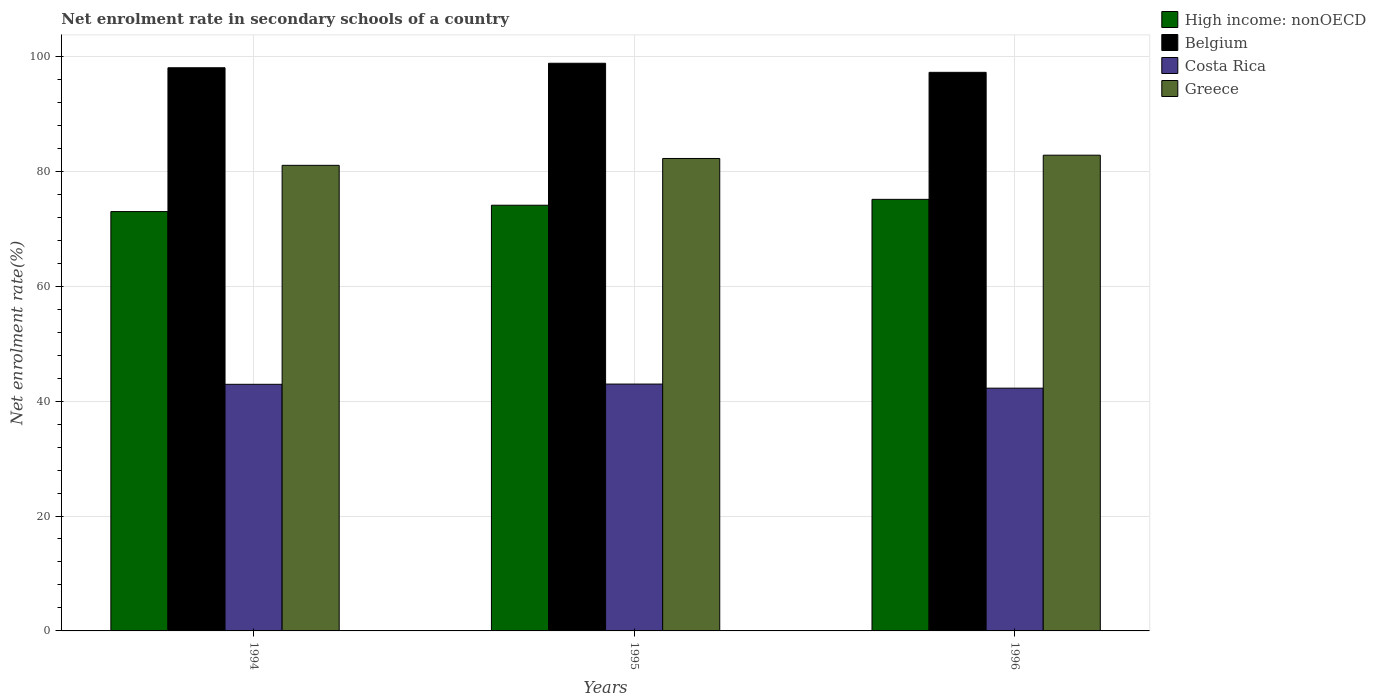How many bars are there on the 1st tick from the left?
Provide a short and direct response. 4. What is the label of the 3rd group of bars from the left?
Offer a very short reply. 1996. What is the net enrolment rate in secondary schools in High income: nonOECD in 1994?
Ensure brevity in your answer.  72.99. Across all years, what is the maximum net enrolment rate in secondary schools in Belgium?
Provide a succinct answer. 98.8. Across all years, what is the minimum net enrolment rate in secondary schools in Greece?
Your response must be concise. 81.04. What is the total net enrolment rate in secondary schools in High income: nonOECD in the graph?
Offer a terse response. 222.2. What is the difference between the net enrolment rate in secondary schools in Greece in 1994 and that in 1995?
Ensure brevity in your answer.  -1.19. What is the difference between the net enrolment rate in secondary schools in High income: nonOECD in 1996 and the net enrolment rate in secondary schools in Costa Rica in 1994?
Give a very brief answer. 32.19. What is the average net enrolment rate in secondary schools in Costa Rica per year?
Provide a short and direct response. 42.71. In the year 1996, what is the difference between the net enrolment rate in secondary schools in High income: nonOECD and net enrolment rate in secondary schools in Costa Rica?
Offer a very short reply. 32.86. What is the ratio of the net enrolment rate in secondary schools in Costa Rica in 1994 to that in 1995?
Give a very brief answer. 1. What is the difference between the highest and the second highest net enrolment rate in secondary schools in High income: nonOECD?
Provide a short and direct response. 1.02. What is the difference between the highest and the lowest net enrolment rate in secondary schools in Costa Rica?
Keep it short and to the point. 0.71. In how many years, is the net enrolment rate in secondary schools in Greece greater than the average net enrolment rate in secondary schools in Greece taken over all years?
Your answer should be very brief. 2. Is the sum of the net enrolment rate in secondary schools in High income: nonOECD in 1994 and 1995 greater than the maximum net enrolment rate in secondary schools in Belgium across all years?
Provide a succinct answer. Yes. Is it the case that in every year, the sum of the net enrolment rate in secondary schools in Costa Rica and net enrolment rate in secondary schools in Belgium is greater than the sum of net enrolment rate in secondary schools in High income: nonOECD and net enrolment rate in secondary schools in Greece?
Provide a succinct answer. Yes. What does the 1st bar from the left in 1995 represents?
Ensure brevity in your answer.  High income: nonOECD. Is it the case that in every year, the sum of the net enrolment rate in secondary schools in High income: nonOECD and net enrolment rate in secondary schools in Greece is greater than the net enrolment rate in secondary schools in Costa Rica?
Offer a terse response. Yes. Are all the bars in the graph horizontal?
Offer a terse response. No. How many years are there in the graph?
Make the answer very short. 3. Are the values on the major ticks of Y-axis written in scientific E-notation?
Offer a terse response. No. Does the graph contain grids?
Your answer should be compact. Yes. How are the legend labels stacked?
Give a very brief answer. Vertical. What is the title of the graph?
Provide a succinct answer. Net enrolment rate in secondary schools of a country. Does "Switzerland" appear as one of the legend labels in the graph?
Provide a succinct answer. No. What is the label or title of the X-axis?
Your answer should be very brief. Years. What is the label or title of the Y-axis?
Ensure brevity in your answer.  Net enrolment rate(%). What is the Net enrolment rate(%) of High income: nonOECD in 1994?
Give a very brief answer. 72.99. What is the Net enrolment rate(%) in Belgium in 1994?
Offer a very short reply. 98.02. What is the Net enrolment rate(%) in Costa Rica in 1994?
Make the answer very short. 42.92. What is the Net enrolment rate(%) of Greece in 1994?
Provide a succinct answer. 81.04. What is the Net enrolment rate(%) of High income: nonOECD in 1995?
Your answer should be compact. 74.09. What is the Net enrolment rate(%) of Belgium in 1995?
Keep it short and to the point. 98.8. What is the Net enrolment rate(%) of Costa Rica in 1995?
Offer a terse response. 42.97. What is the Net enrolment rate(%) of Greece in 1995?
Your answer should be very brief. 82.23. What is the Net enrolment rate(%) in High income: nonOECD in 1996?
Make the answer very short. 75.12. What is the Net enrolment rate(%) in Belgium in 1996?
Offer a terse response. 97.22. What is the Net enrolment rate(%) in Costa Rica in 1996?
Your response must be concise. 42.25. What is the Net enrolment rate(%) in Greece in 1996?
Keep it short and to the point. 82.8. Across all years, what is the maximum Net enrolment rate(%) in High income: nonOECD?
Your response must be concise. 75.12. Across all years, what is the maximum Net enrolment rate(%) in Belgium?
Give a very brief answer. 98.8. Across all years, what is the maximum Net enrolment rate(%) of Costa Rica?
Your response must be concise. 42.97. Across all years, what is the maximum Net enrolment rate(%) in Greece?
Offer a very short reply. 82.8. Across all years, what is the minimum Net enrolment rate(%) of High income: nonOECD?
Provide a short and direct response. 72.99. Across all years, what is the minimum Net enrolment rate(%) of Belgium?
Provide a short and direct response. 97.22. Across all years, what is the minimum Net enrolment rate(%) of Costa Rica?
Offer a very short reply. 42.25. Across all years, what is the minimum Net enrolment rate(%) in Greece?
Ensure brevity in your answer.  81.04. What is the total Net enrolment rate(%) of High income: nonOECD in the graph?
Offer a very short reply. 222.2. What is the total Net enrolment rate(%) of Belgium in the graph?
Your answer should be compact. 294.04. What is the total Net enrolment rate(%) of Costa Rica in the graph?
Give a very brief answer. 128.14. What is the total Net enrolment rate(%) of Greece in the graph?
Offer a very short reply. 246.07. What is the difference between the Net enrolment rate(%) in High income: nonOECD in 1994 and that in 1995?
Your answer should be very brief. -1.1. What is the difference between the Net enrolment rate(%) in Belgium in 1994 and that in 1995?
Make the answer very short. -0.78. What is the difference between the Net enrolment rate(%) in Costa Rica in 1994 and that in 1995?
Give a very brief answer. -0.04. What is the difference between the Net enrolment rate(%) of Greece in 1994 and that in 1995?
Provide a succinct answer. -1.19. What is the difference between the Net enrolment rate(%) of High income: nonOECD in 1994 and that in 1996?
Offer a very short reply. -2.13. What is the difference between the Net enrolment rate(%) of Belgium in 1994 and that in 1996?
Ensure brevity in your answer.  0.8. What is the difference between the Net enrolment rate(%) of Costa Rica in 1994 and that in 1996?
Offer a terse response. 0.67. What is the difference between the Net enrolment rate(%) in Greece in 1994 and that in 1996?
Offer a very short reply. -1.76. What is the difference between the Net enrolment rate(%) of High income: nonOECD in 1995 and that in 1996?
Give a very brief answer. -1.02. What is the difference between the Net enrolment rate(%) in Belgium in 1995 and that in 1996?
Provide a short and direct response. 1.58. What is the difference between the Net enrolment rate(%) in Costa Rica in 1995 and that in 1996?
Keep it short and to the point. 0.71. What is the difference between the Net enrolment rate(%) of Greece in 1995 and that in 1996?
Make the answer very short. -0.57. What is the difference between the Net enrolment rate(%) in High income: nonOECD in 1994 and the Net enrolment rate(%) in Belgium in 1995?
Give a very brief answer. -25.81. What is the difference between the Net enrolment rate(%) of High income: nonOECD in 1994 and the Net enrolment rate(%) of Costa Rica in 1995?
Offer a very short reply. 30.02. What is the difference between the Net enrolment rate(%) of High income: nonOECD in 1994 and the Net enrolment rate(%) of Greece in 1995?
Your answer should be very brief. -9.24. What is the difference between the Net enrolment rate(%) in Belgium in 1994 and the Net enrolment rate(%) in Costa Rica in 1995?
Offer a very short reply. 55.05. What is the difference between the Net enrolment rate(%) of Belgium in 1994 and the Net enrolment rate(%) of Greece in 1995?
Your answer should be very brief. 15.79. What is the difference between the Net enrolment rate(%) of Costa Rica in 1994 and the Net enrolment rate(%) of Greece in 1995?
Make the answer very short. -39.31. What is the difference between the Net enrolment rate(%) in High income: nonOECD in 1994 and the Net enrolment rate(%) in Belgium in 1996?
Keep it short and to the point. -24.23. What is the difference between the Net enrolment rate(%) in High income: nonOECD in 1994 and the Net enrolment rate(%) in Costa Rica in 1996?
Offer a very short reply. 30.74. What is the difference between the Net enrolment rate(%) of High income: nonOECD in 1994 and the Net enrolment rate(%) of Greece in 1996?
Your answer should be very brief. -9.81. What is the difference between the Net enrolment rate(%) in Belgium in 1994 and the Net enrolment rate(%) in Costa Rica in 1996?
Provide a succinct answer. 55.77. What is the difference between the Net enrolment rate(%) of Belgium in 1994 and the Net enrolment rate(%) of Greece in 1996?
Provide a short and direct response. 15.22. What is the difference between the Net enrolment rate(%) in Costa Rica in 1994 and the Net enrolment rate(%) in Greece in 1996?
Keep it short and to the point. -39.88. What is the difference between the Net enrolment rate(%) of High income: nonOECD in 1995 and the Net enrolment rate(%) of Belgium in 1996?
Make the answer very short. -23.13. What is the difference between the Net enrolment rate(%) of High income: nonOECD in 1995 and the Net enrolment rate(%) of Costa Rica in 1996?
Provide a succinct answer. 31.84. What is the difference between the Net enrolment rate(%) of High income: nonOECD in 1995 and the Net enrolment rate(%) of Greece in 1996?
Give a very brief answer. -8.71. What is the difference between the Net enrolment rate(%) in Belgium in 1995 and the Net enrolment rate(%) in Costa Rica in 1996?
Provide a succinct answer. 56.55. What is the difference between the Net enrolment rate(%) of Belgium in 1995 and the Net enrolment rate(%) of Greece in 1996?
Make the answer very short. 16. What is the difference between the Net enrolment rate(%) in Costa Rica in 1995 and the Net enrolment rate(%) in Greece in 1996?
Your answer should be compact. -39.83. What is the average Net enrolment rate(%) of High income: nonOECD per year?
Make the answer very short. 74.07. What is the average Net enrolment rate(%) in Belgium per year?
Ensure brevity in your answer.  98.02. What is the average Net enrolment rate(%) of Costa Rica per year?
Ensure brevity in your answer.  42.71. What is the average Net enrolment rate(%) of Greece per year?
Provide a short and direct response. 82.02. In the year 1994, what is the difference between the Net enrolment rate(%) in High income: nonOECD and Net enrolment rate(%) in Belgium?
Offer a terse response. -25.03. In the year 1994, what is the difference between the Net enrolment rate(%) in High income: nonOECD and Net enrolment rate(%) in Costa Rica?
Your response must be concise. 30.06. In the year 1994, what is the difference between the Net enrolment rate(%) of High income: nonOECD and Net enrolment rate(%) of Greece?
Ensure brevity in your answer.  -8.05. In the year 1994, what is the difference between the Net enrolment rate(%) of Belgium and Net enrolment rate(%) of Costa Rica?
Your answer should be compact. 55.09. In the year 1994, what is the difference between the Net enrolment rate(%) of Belgium and Net enrolment rate(%) of Greece?
Give a very brief answer. 16.98. In the year 1994, what is the difference between the Net enrolment rate(%) in Costa Rica and Net enrolment rate(%) in Greece?
Offer a very short reply. -38.11. In the year 1995, what is the difference between the Net enrolment rate(%) of High income: nonOECD and Net enrolment rate(%) of Belgium?
Ensure brevity in your answer.  -24.71. In the year 1995, what is the difference between the Net enrolment rate(%) in High income: nonOECD and Net enrolment rate(%) in Costa Rica?
Make the answer very short. 31.13. In the year 1995, what is the difference between the Net enrolment rate(%) in High income: nonOECD and Net enrolment rate(%) in Greece?
Provide a succinct answer. -8.14. In the year 1995, what is the difference between the Net enrolment rate(%) in Belgium and Net enrolment rate(%) in Costa Rica?
Offer a very short reply. 55.84. In the year 1995, what is the difference between the Net enrolment rate(%) of Belgium and Net enrolment rate(%) of Greece?
Ensure brevity in your answer.  16.57. In the year 1995, what is the difference between the Net enrolment rate(%) in Costa Rica and Net enrolment rate(%) in Greece?
Provide a succinct answer. -39.26. In the year 1996, what is the difference between the Net enrolment rate(%) of High income: nonOECD and Net enrolment rate(%) of Belgium?
Give a very brief answer. -22.11. In the year 1996, what is the difference between the Net enrolment rate(%) of High income: nonOECD and Net enrolment rate(%) of Costa Rica?
Your answer should be compact. 32.86. In the year 1996, what is the difference between the Net enrolment rate(%) of High income: nonOECD and Net enrolment rate(%) of Greece?
Ensure brevity in your answer.  -7.68. In the year 1996, what is the difference between the Net enrolment rate(%) in Belgium and Net enrolment rate(%) in Costa Rica?
Your response must be concise. 54.97. In the year 1996, what is the difference between the Net enrolment rate(%) of Belgium and Net enrolment rate(%) of Greece?
Offer a terse response. 14.42. In the year 1996, what is the difference between the Net enrolment rate(%) of Costa Rica and Net enrolment rate(%) of Greece?
Offer a very short reply. -40.55. What is the ratio of the Net enrolment rate(%) of High income: nonOECD in 1994 to that in 1995?
Make the answer very short. 0.99. What is the ratio of the Net enrolment rate(%) of Belgium in 1994 to that in 1995?
Give a very brief answer. 0.99. What is the ratio of the Net enrolment rate(%) in Greece in 1994 to that in 1995?
Your response must be concise. 0.99. What is the ratio of the Net enrolment rate(%) of High income: nonOECD in 1994 to that in 1996?
Make the answer very short. 0.97. What is the ratio of the Net enrolment rate(%) of Belgium in 1994 to that in 1996?
Make the answer very short. 1.01. What is the ratio of the Net enrolment rate(%) in Costa Rica in 1994 to that in 1996?
Offer a very short reply. 1.02. What is the ratio of the Net enrolment rate(%) of Greece in 1994 to that in 1996?
Your response must be concise. 0.98. What is the ratio of the Net enrolment rate(%) in High income: nonOECD in 1995 to that in 1996?
Make the answer very short. 0.99. What is the ratio of the Net enrolment rate(%) in Belgium in 1995 to that in 1996?
Your answer should be very brief. 1.02. What is the ratio of the Net enrolment rate(%) in Costa Rica in 1995 to that in 1996?
Keep it short and to the point. 1.02. What is the ratio of the Net enrolment rate(%) in Greece in 1995 to that in 1996?
Provide a succinct answer. 0.99. What is the difference between the highest and the second highest Net enrolment rate(%) in High income: nonOECD?
Offer a terse response. 1.02. What is the difference between the highest and the second highest Net enrolment rate(%) in Belgium?
Your answer should be very brief. 0.78. What is the difference between the highest and the second highest Net enrolment rate(%) of Costa Rica?
Give a very brief answer. 0.04. What is the difference between the highest and the second highest Net enrolment rate(%) in Greece?
Give a very brief answer. 0.57. What is the difference between the highest and the lowest Net enrolment rate(%) in High income: nonOECD?
Keep it short and to the point. 2.13. What is the difference between the highest and the lowest Net enrolment rate(%) in Belgium?
Ensure brevity in your answer.  1.58. What is the difference between the highest and the lowest Net enrolment rate(%) of Costa Rica?
Your answer should be compact. 0.71. What is the difference between the highest and the lowest Net enrolment rate(%) in Greece?
Your response must be concise. 1.76. 